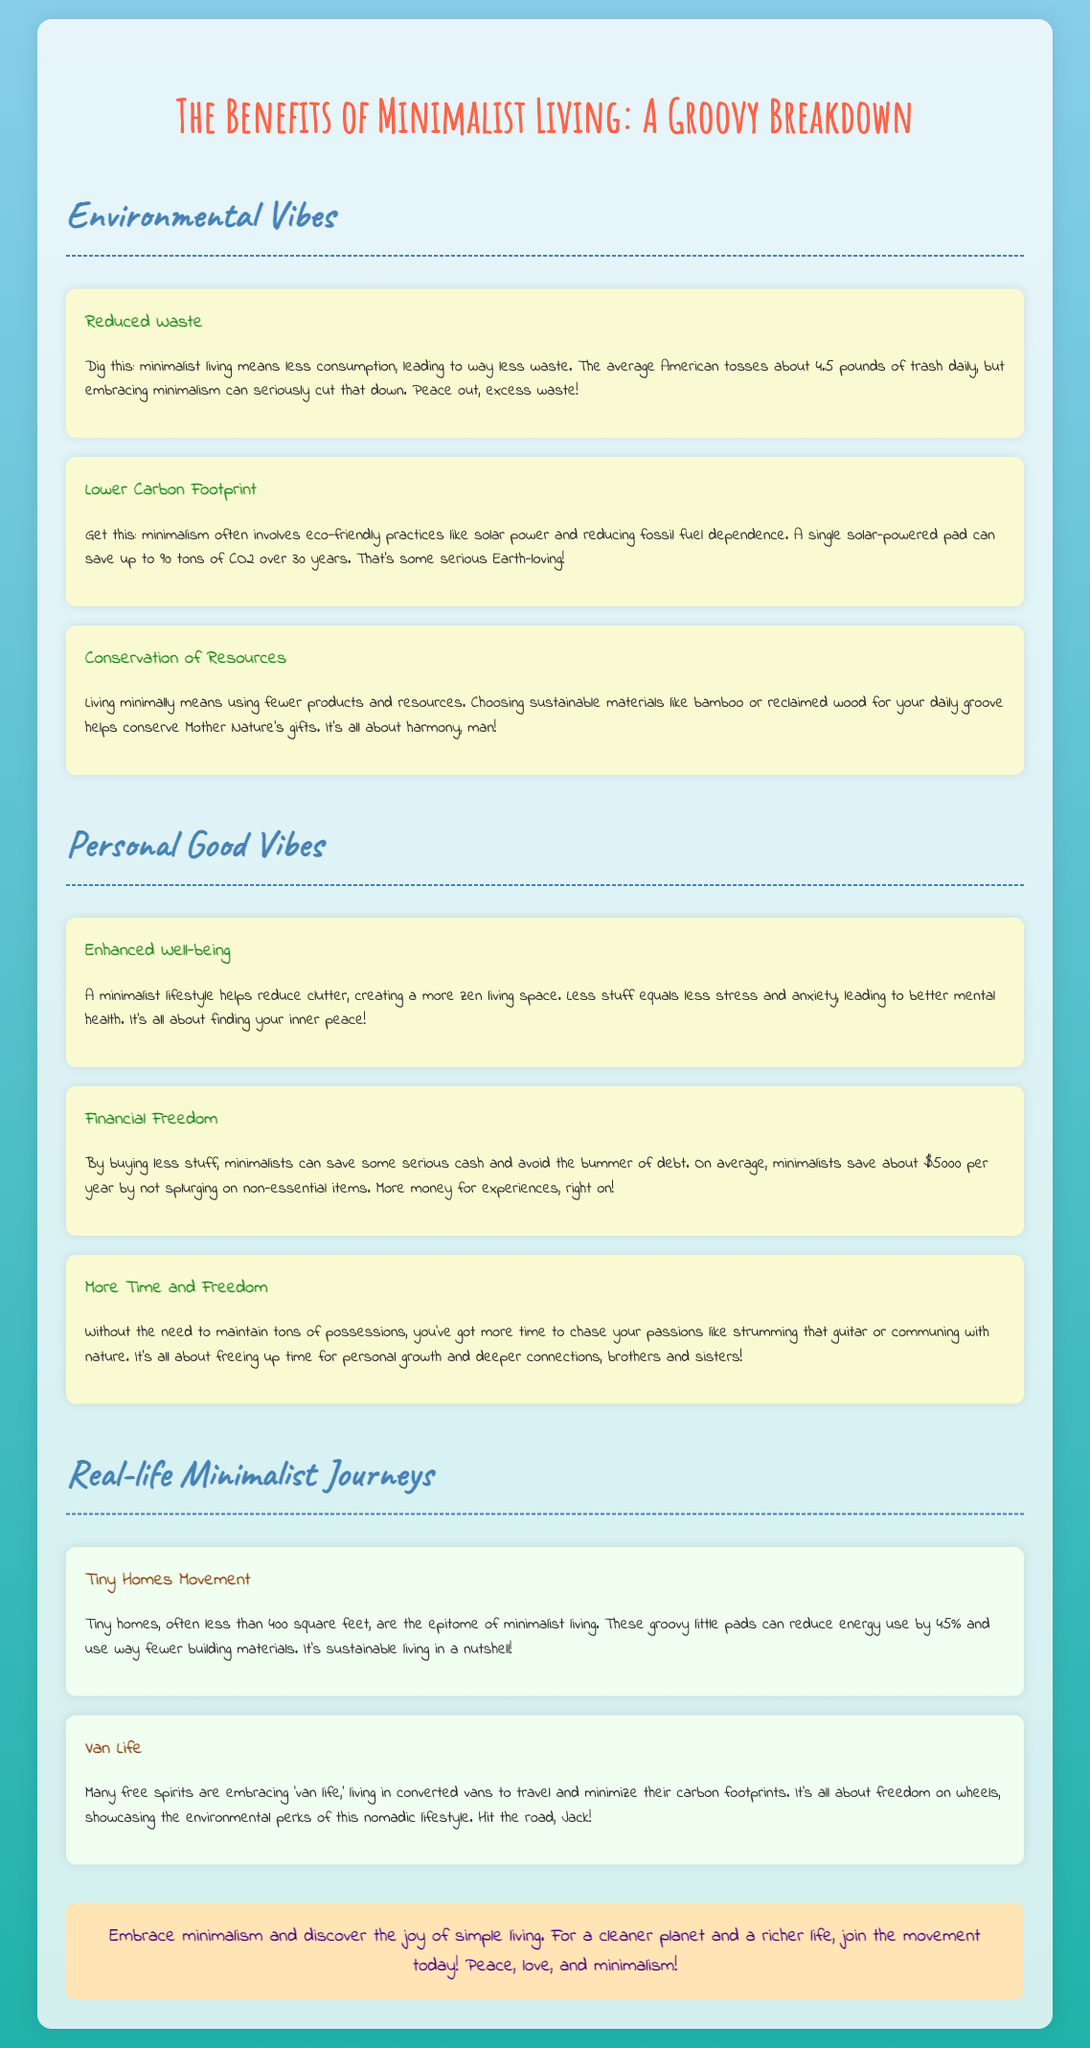what is the average amount of trash an American tosses daily? The document states that the average American tosses about 4.5 pounds of trash daily.
Answer: 4.5 pounds how much CO2 can a single solar-powered pad save over 30 years? The document mentions that a single solar-powered pad can save up to 90 tons of CO2 over 30 years.
Answer: 90 tons what financial benefit do minimalists typically experience per year? According to the document, minimalists save about $5000 per year by not splurging on non-essential items.
Answer: $5000 what are tiny homes typically less than in square feet? The document describes tiny homes as being often less than 400 square feet.
Answer: 400 square feet what lifestyle captures the essence of freedom on wheels? The document highlights 'van life' as a lifestyle showcasing environmental perks and freedom on wheels.
Answer: van life which environmental benefit involves conserving materials? The document talks about choosing sustainable materials to conserve Mother Nature's gifts as a benefit.
Answer: Conservation of Resources what is a common outcome of a minimalist lifestyle in terms of mental health? The document states that a minimalist lifestyle helps reduce clutter, leading to better mental health.
Answer: Enhanced Well-being what is the overarching theme of the infographic? The document emphasizes the joys and benefits of simple living through minimalism.
Answer: The Benefits of Minimalist Living 